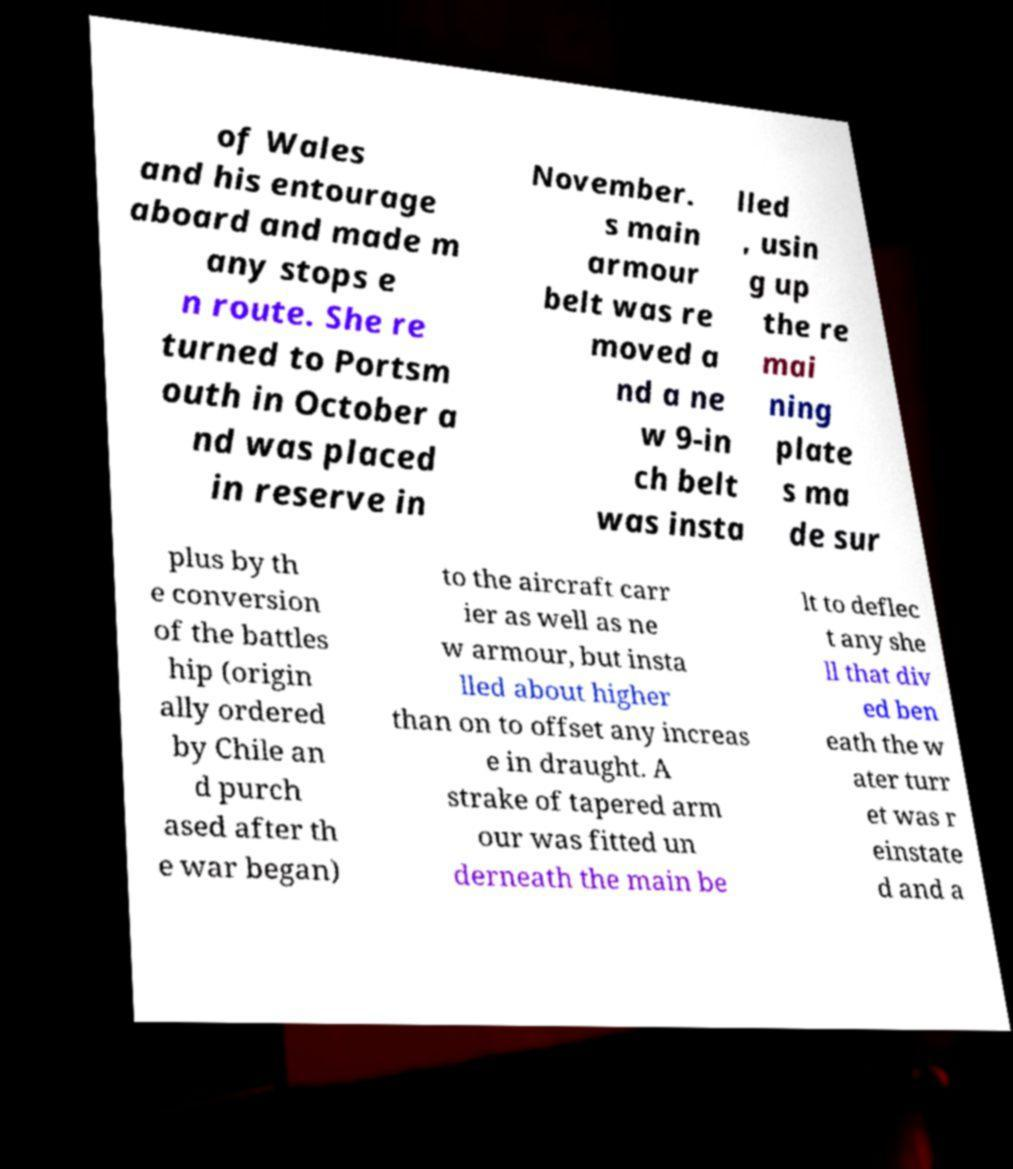Could you assist in decoding the text presented in this image and type it out clearly? of Wales and his entourage aboard and made m any stops e n route. She re turned to Portsm outh in October a nd was placed in reserve in November. s main armour belt was re moved a nd a ne w 9-in ch belt was insta lled , usin g up the re mai ning plate s ma de sur plus by th e conversion of the battles hip (origin ally ordered by Chile an d purch ased after th e war began) to the aircraft carr ier as well as ne w armour, but insta lled about higher than on to offset any increas e in draught. A strake of tapered arm our was fitted un derneath the main be lt to deflec t any she ll that div ed ben eath the w ater turr et was r einstate d and a 